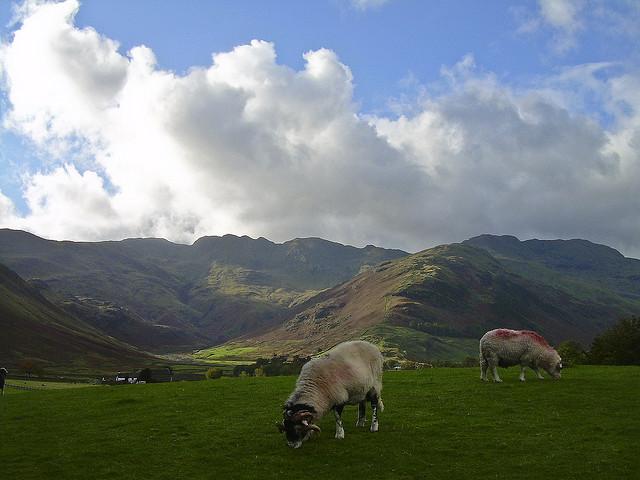Is the animal standing?
Quick response, please. Yes. Are the mountains made of igneous or sedimentary rock?
Short answer required. Sedimentary. Are the cloud nimbus or cirrus?
Concise answer only. Nimbus. What kind of clouds are pictured?
Be succinct. Cumulus. What is the animal?
Keep it brief. Sheep. What position is the animal in?
Write a very short answer. Standing. What are the sheep grazing on?
Keep it brief. Grass. What kind of animals can you see?
Answer briefly. Sheep. 